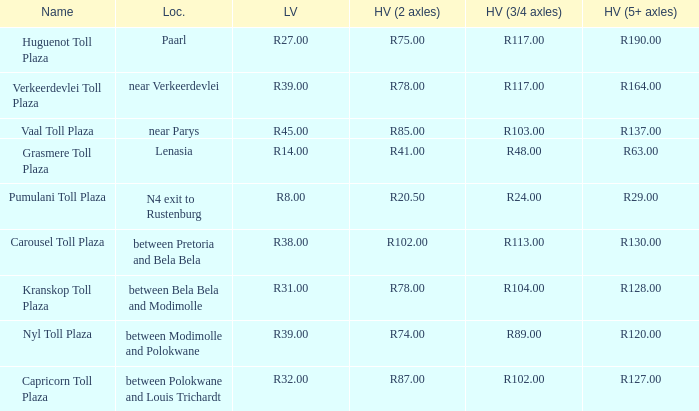What is the toll for heavy vehicles with 3/4 axles at Verkeerdevlei toll plaza? R117.00. 